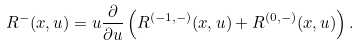Convert formula to latex. <formula><loc_0><loc_0><loc_500><loc_500>R ^ { - } ( x , u ) = u \frac { \partial } { \partial u } \left ( R ^ { ( - 1 , - ) } ( x , u ) + R ^ { ( 0 , - ) } ( x , u ) \right ) .</formula> 